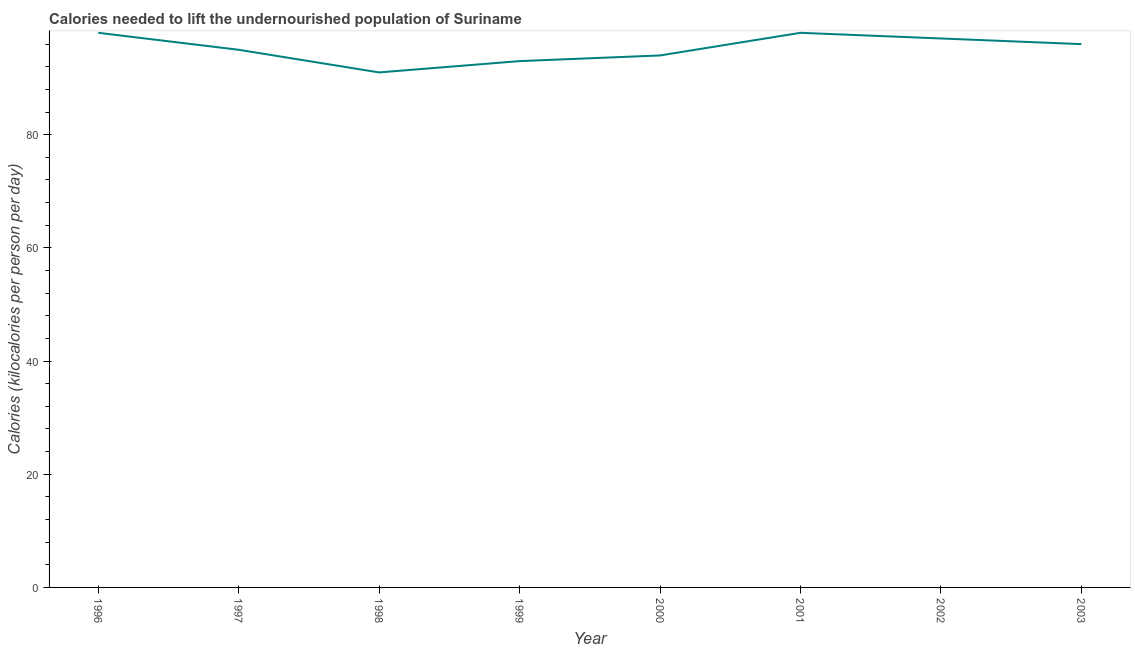What is the depth of food deficit in 2000?
Your answer should be very brief. 94. Across all years, what is the maximum depth of food deficit?
Your answer should be very brief. 98. Across all years, what is the minimum depth of food deficit?
Give a very brief answer. 91. In which year was the depth of food deficit maximum?
Give a very brief answer. 1996. In which year was the depth of food deficit minimum?
Offer a very short reply. 1998. What is the sum of the depth of food deficit?
Give a very brief answer. 762. What is the difference between the depth of food deficit in 1997 and 2002?
Your answer should be very brief. -2. What is the average depth of food deficit per year?
Make the answer very short. 95.25. What is the median depth of food deficit?
Keep it short and to the point. 95.5. In how many years, is the depth of food deficit greater than 28 kilocalories?
Provide a succinct answer. 8. Do a majority of the years between 1999 and 1997 (inclusive) have depth of food deficit greater than 36 kilocalories?
Offer a very short reply. No. What is the ratio of the depth of food deficit in 1998 to that in 2002?
Make the answer very short. 0.94. What is the difference between the highest and the lowest depth of food deficit?
Your response must be concise. 7. Does the depth of food deficit monotonically increase over the years?
Ensure brevity in your answer.  No. How many lines are there?
Your response must be concise. 1. How many years are there in the graph?
Provide a short and direct response. 8. Are the values on the major ticks of Y-axis written in scientific E-notation?
Offer a terse response. No. Does the graph contain any zero values?
Offer a terse response. No. Does the graph contain grids?
Your response must be concise. No. What is the title of the graph?
Make the answer very short. Calories needed to lift the undernourished population of Suriname. What is the label or title of the Y-axis?
Provide a short and direct response. Calories (kilocalories per person per day). What is the Calories (kilocalories per person per day) of 1997?
Give a very brief answer. 95. What is the Calories (kilocalories per person per day) in 1998?
Offer a very short reply. 91. What is the Calories (kilocalories per person per day) in 1999?
Provide a short and direct response. 93. What is the Calories (kilocalories per person per day) of 2000?
Your response must be concise. 94. What is the Calories (kilocalories per person per day) of 2002?
Make the answer very short. 97. What is the Calories (kilocalories per person per day) of 2003?
Provide a short and direct response. 96. What is the difference between the Calories (kilocalories per person per day) in 1996 and 1997?
Give a very brief answer. 3. What is the difference between the Calories (kilocalories per person per day) in 1996 and 2001?
Provide a short and direct response. 0. What is the difference between the Calories (kilocalories per person per day) in 1996 and 2003?
Offer a very short reply. 2. What is the difference between the Calories (kilocalories per person per day) in 1997 and 1999?
Offer a very short reply. 2. What is the difference between the Calories (kilocalories per person per day) in 1997 and 2001?
Your answer should be compact. -3. What is the difference between the Calories (kilocalories per person per day) in 1997 and 2002?
Your answer should be very brief. -2. What is the difference between the Calories (kilocalories per person per day) in 1998 and 1999?
Your answer should be compact. -2. What is the difference between the Calories (kilocalories per person per day) in 1998 and 2001?
Give a very brief answer. -7. What is the difference between the Calories (kilocalories per person per day) in 1998 and 2002?
Offer a terse response. -6. What is the difference between the Calories (kilocalories per person per day) in 1999 and 2000?
Provide a short and direct response. -1. What is the difference between the Calories (kilocalories per person per day) in 1999 and 2002?
Provide a short and direct response. -4. What is the difference between the Calories (kilocalories per person per day) in 2000 and 2001?
Give a very brief answer. -4. What is the difference between the Calories (kilocalories per person per day) in 2000 and 2002?
Your answer should be very brief. -3. What is the difference between the Calories (kilocalories per person per day) in 2001 and 2002?
Offer a terse response. 1. What is the ratio of the Calories (kilocalories per person per day) in 1996 to that in 1997?
Offer a very short reply. 1.03. What is the ratio of the Calories (kilocalories per person per day) in 1996 to that in 1998?
Your answer should be very brief. 1.08. What is the ratio of the Calories (kilocalories per person per day) in 1996 to that in 1999?
Ensure brevity in your answer.  1.05. What is the ratio of the Calories (kilocalories per person per day) in 1996 to that in 2000?
Offer a terse response. 1.04. What is the ratio of the Calories (kilocalories per person per day) in 1996 to that in 2001?
Give a very brief answer. 1. What is the ratio of the Calories (kilocalories per person per day) in 1996 to that in 2002?
Offer a terse response. 1.01. What is the ratio of the Calories (kilocalories per person per day) in 1996 to that in 2003?
Ensure brevity in your answer.  1.02. What is the ratio of the Calories (kilocalories per person per day) in 1997 to that in 1998?
Provide a short and direct response. 1.04. What is the ratio of the Calories (kilocalories per person per day) in 1997 to that in 1999?
Keep it short and to the point. 1.02. What is the ratio of the Calories (kilocalories per person per day) in 1997 to that in 2000?
Ensure brevity in your answer.  1.01. What is the ratio of the Calories (kilocalories per person per day) in 1997 to that in 2001?
Provide a succinct answer. 0.97. What is the ratio of the Calories (kilocalories per person per day) in 1998 to that in 2000?
Give a very brief answer. 0.97. What is the ratio of the Calories (kilocalories per person per day) in 1998 to that in 2001?
Your response must be concise. 0.93. What is the ratio of the Calories (kilocalories per person per day) in 1998 to that in 2002?
Keep it short and to the point. 0.94. What is the ratio of the Calories (kilocalories per person per day) in 1998 to that in 2003?
Make the answer very short. 0.95. What is the ratio of the Calories (kilocalories per person per day) in 1999 to that in 2000?
Your answer should be compact. 0.99. What is the ratio of the Calories (kilocalories per person per day) in 1999 to that in 2001?
Ensure brevity in your answer.  0.95. What is the ratio of the Calories (kilocalories per person per day) in 1999 to that in 2002?
Offer a very short reply. 0.96. What is the ratio of the Calories (kilocalories per person per day) in 2000 to that in 2001?
Your answer should be very brief. 0.96. 